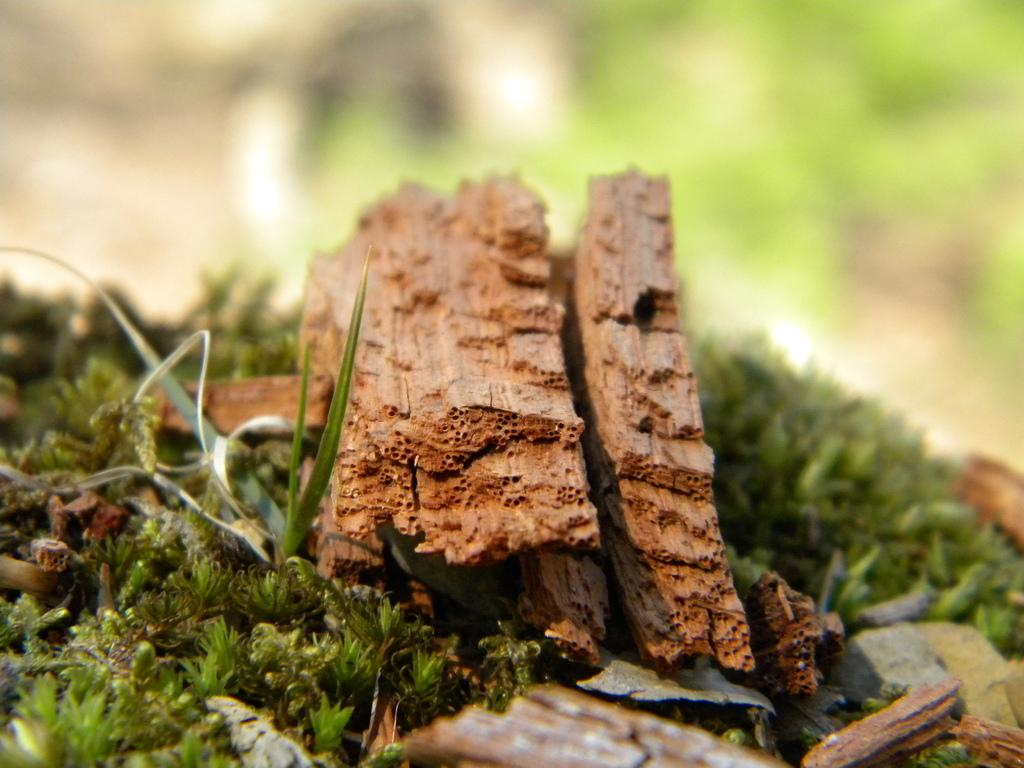What is the main subject of the image? The main subject of the image is a broken leg. Where is the broken leg located? The broken leg is on a grassland. What type of account is being discussed in the image? There is no account being discussed in the image; it features a broken leg on a grassland. Is the broken leg located on an island in the image? There is no island present in the image; it features a broken leg on a grassland. 